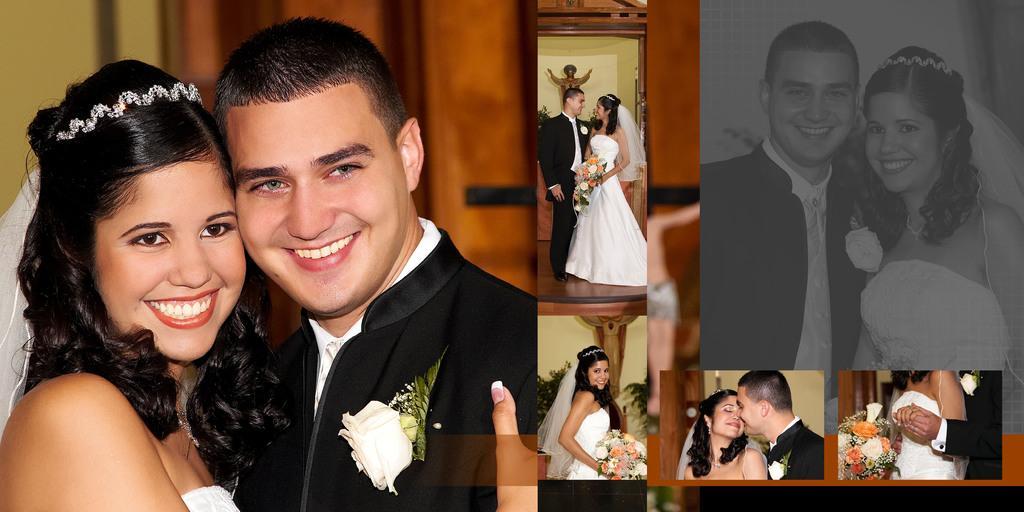How would you summarize this image in a sentence or two? This is a collage in this image there is a person and a woman and they are holding flower bouquet, and in the background there is a statue and some plants, wall and door. 